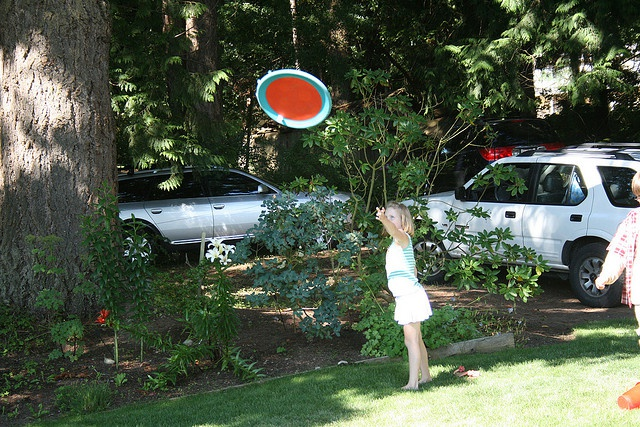Describe the objects in this image and their specific colors. I can see car in black, white, lightblue, and gray tones, car in black, teal, and lightblue tones, people in black, white, darkgray, and tan tones, people in black, white, gray, and lightpink tones, and frisbee in black, red, white, and teal tones in this image. 